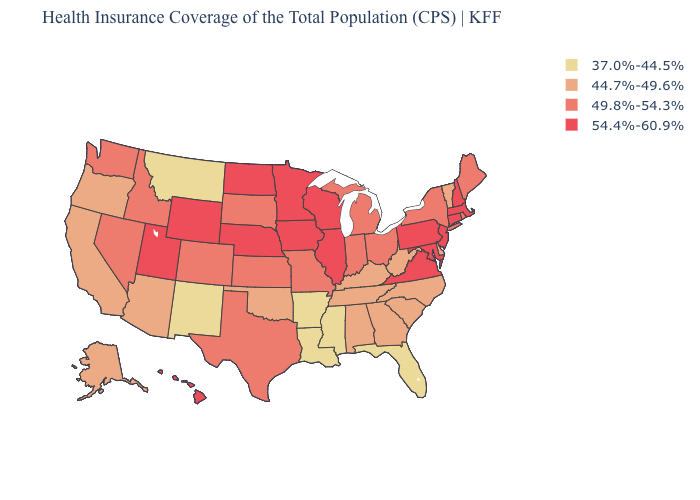What is the highest value in states that border Vermont?
Give a very brief answer. 54.4%-60.9%. Among the states that border South Carolina , which have the lowest value?
Keep it brief. Georgia, North Carolina. Name the states that have a value in the range 37.0%-44.5%?
Answer briefly. Arkansas, Florida, Louisiana, Mississippi, Montana, New Mexico. What is the lowest value in the USA?
Answer briefly. 37.0%-44.5%. Among the states that border Minnesota , which have the highest value?
Concise answer only. Iowa, North Dakota, Wisconsin. Among the states that border Michigan , does Wisconsin have the highest value?
Write a very short answer. Yes. Name the states that have a value in the range 44.7%-49.6%?
Answer briefly. Alabama, Alaska, Arizona, California, Delaware, Georgia, Kentucky, North Carolina, Oklahoma, Oregon, South Carolina, Tennessee, Vermont, West Virginia. How many symbols are there in the legend?
Short answer required. 4. Does North Dakota have the lowest value in the USA?
Be succinct. No. What is the lowest value in the West?
Keep it brief. 37.0%-44.5%. Does the map have missing data?
Write a very short answer. No. Does the first symbol in the legend represent the smallest category?
Be succinct. Yes. Among the states that border New Mexico , does Oklahoma have the highest value?
Give a very brief answer. No. Name the states that have a value in the range 54.4%-60.9%?
Keep it brief. Connecticut, Hawaii, Illinois, Iowa, Maryland, Massachusetts, Minnesota, Nebraska, New Hampshire, New Jersey, North Dakota, Pennsylvania, Utah, Virginia, Wisconsin, Wyoming. Name the states that have a value in the range 49.8%-54.3%?
Answer briefly. Colorado, Idaho, Indiana, Kansas, Maine, Michigan, Missouri, Nevada, New York, Ohio, Rhode Island, South Dakota, Texas, Washington. 